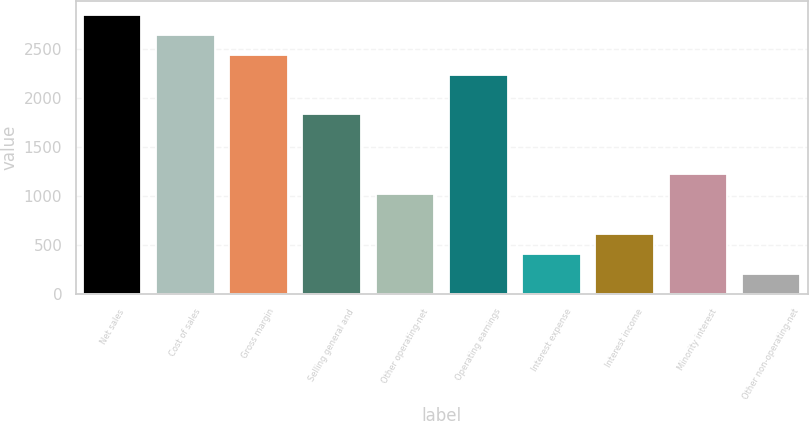<chart> <loc_0><loc_0><loc_500><loc_500><bar_chart><fcel>Net sales<fcel>Cost of sales<fcel>Gross margin<fcel>Selling general and<fcel>Other operating-net<fcel>Operating earnings<fcel>Interest expense<fcel>Interest income<fcel>Minority interest<fcel>Other non-operating-net<nl><fcel>2845.82<fcel>2642.59<fcel>2439.36<fcel>1829.67<fcel>1016.75<fcel>2236.13<fcel>407.06<fcel>610.29<fcel>1219.98<fcel>203.83<nl></chart> 